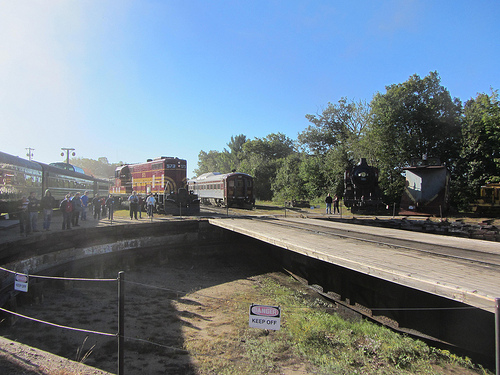Who is standing near the black train? People are standing near the black train. 